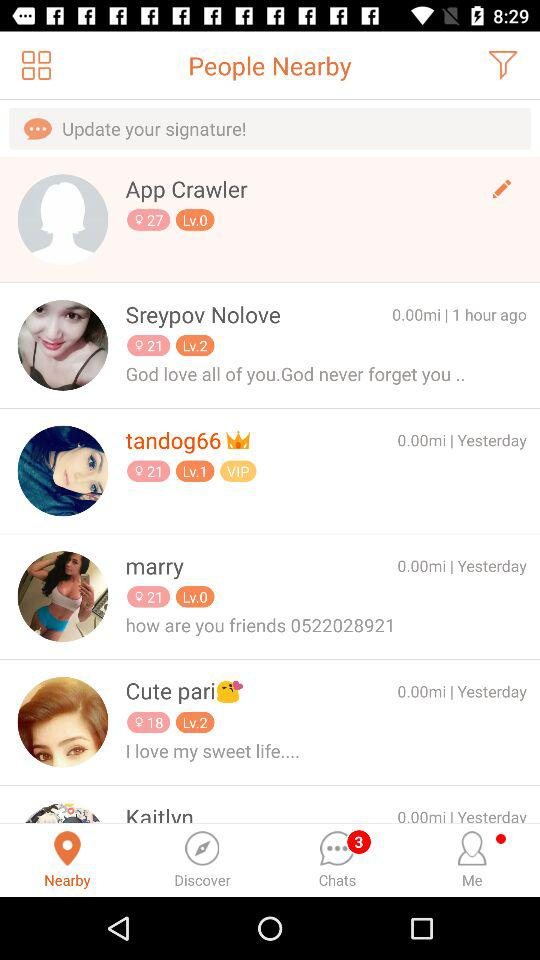Marry's last post was how many days ago?
When the provided information is insufficient, respond with <no answer>. <no answer> 